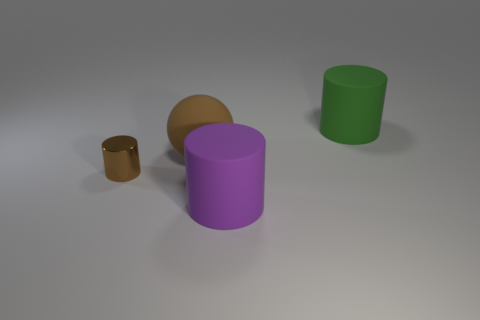Add 2 tiny blue cylinders. How many objects exist? 6 Subtract all spheres. How many objects are left? 3 Add 4 big purple rubber cylinders. How many big purple rubber cylinders are left? 5 Add 4 yellow cubes. How many yellow cubes exist? 4 Subtract 0 blue cylinders. How many objects are left? 4 Subtract all big purple rubber cylinders. Subtract all brown metal objects. How many objects are left? 2 